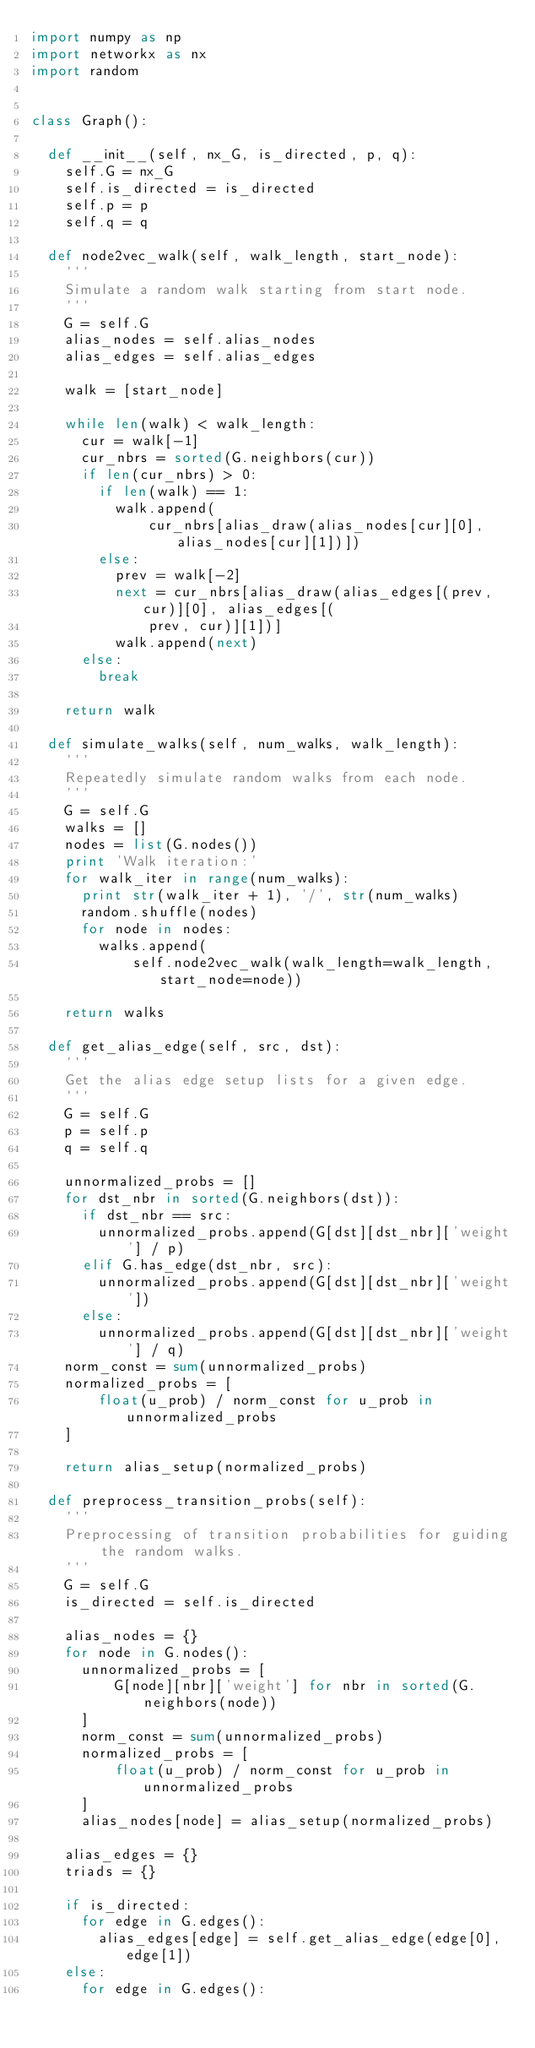Convert code to text. <code><loc_0><loc_0><loc_500><loc_500><_Python_>import numpy as np
import networkx as nx
import random


class Graph():

  def __init__(self, nx_G, is_directed, p, q):
    self.G = nx_G
    self.is_directed = is_directed
    self.p = p
    self.q = q

  def node2vec_walk(self, walk_length, start_node):
    '''
    Simulate a random walk starting from start node.
    '''
    G = self.G
    alias_nodes = self.alias_nodes
    alias_edges = self.alias_edges

    walk = [start_node]

    while len(walk) < walk_length:
      cur = walk[-1]
      cur_nbrs = sorted(G.neighbors(cur))
      if len(cur_nbrs) > 0:
        if len(walk) == 1:
          walk.append(
              cur_nbrs[alias_draw(alias_nodes[cur][0], alias_nodes[cur][1])])
        else:
          prev = walk[-2]
          next = cur_nbrs[alias_draw(alias_edges[(prev, cur)][0], alias_edges[(
              prev, cur)][1])]
          walk.append(next)
      else:
        break

    return walk

  def simulate_walks(self, num_walks, walk_length):
    '''
    Repeatedly simulate random walks from each node.
    '''
    G = self.G
    walks = []
    nodes = list(G.nodes())
    print 'Walk iteration:'
    for walk_iter in range(num_walks):
      print str(walk_iter + 1), '/', str(num_walks)
      random.shuffle(nodes)
      for node in nodes:
        walks.append(
            self.node2vec_walk(walk_length=walk_length, start_node=node))

    return walks

  def get_alias_edge(self, src, dst):
    '''
    Get the alias edge setup lists for a given edge.
    '''
    G = self.G
    p = self.p
    q = self.q

    unnormalized_probs = []
    for dst_nbr in sorted(G.neighbors(dst)):
      if dst_nbr == src:
        unnormalized_probs.append(G[dst][dst_nbr]['weight'] / p)
      elif G.has_edge(dst_nbr, src):
        unnormalized_probs.append(G[dst][dst_nbr]['weight'])
      else:
        unnormalized_probs.append(G[dst][dst_nbr]['weight'] / q)
    norm_const = sum(unnormalized_probs)
    normalized_probs = [
        float(u_prob) / norm_const for u_prob in unnormalized_probs
    ]

    return alias_setup(normalized_probs)

  def preprocess_transition_probs(self):
    '''
    Preprocessing of transition probabilities for guiding the random walks.
    '''
    G = self.G
    is_directed = self.is_directed

    alias_nodes = {}
    for node in G.nodes():
      unnormalized_probs = [
          G[node][nbr]['weight'] for nbr in sorted(G.neighbors(node))
      ]
      norm_const = sum(unnormalized_probs)
      normalized_probs = [
          float(u_prob) / norm_const for u_prob in unnormalized_probs
      ]
      alias_nodes[node] = alias_setup(normalized_probs)

    alias_edges = {}
    triads = {}

    if is_directed:
      for edge in G.edges():
        alias_edges[edge] = self.get_alias_edge(edge[0], edge[1])
    else:
      for edge in G.edges():</code> 